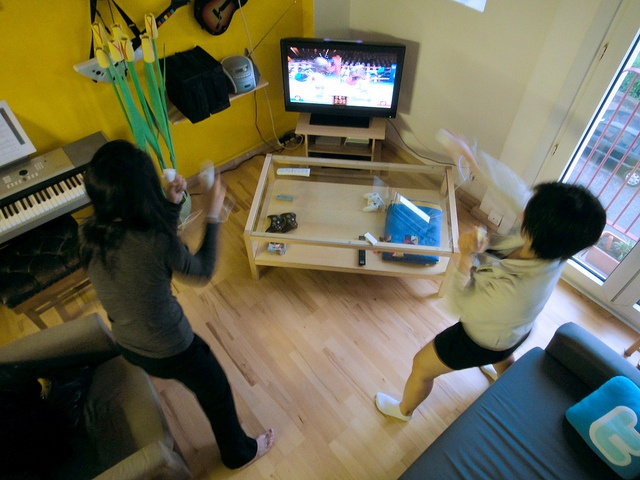Describe the objects in this image and their specific colors. I can see people in olive, black, and gray tones, chair in olive, black, darkgreen, and gray tones, people in olive, black, tan, darkgray, and gray tones, couch in olive, black, darkgreen, and gray tones, and couch in olive, blue, black, teal, and darkblue tones in this image. 